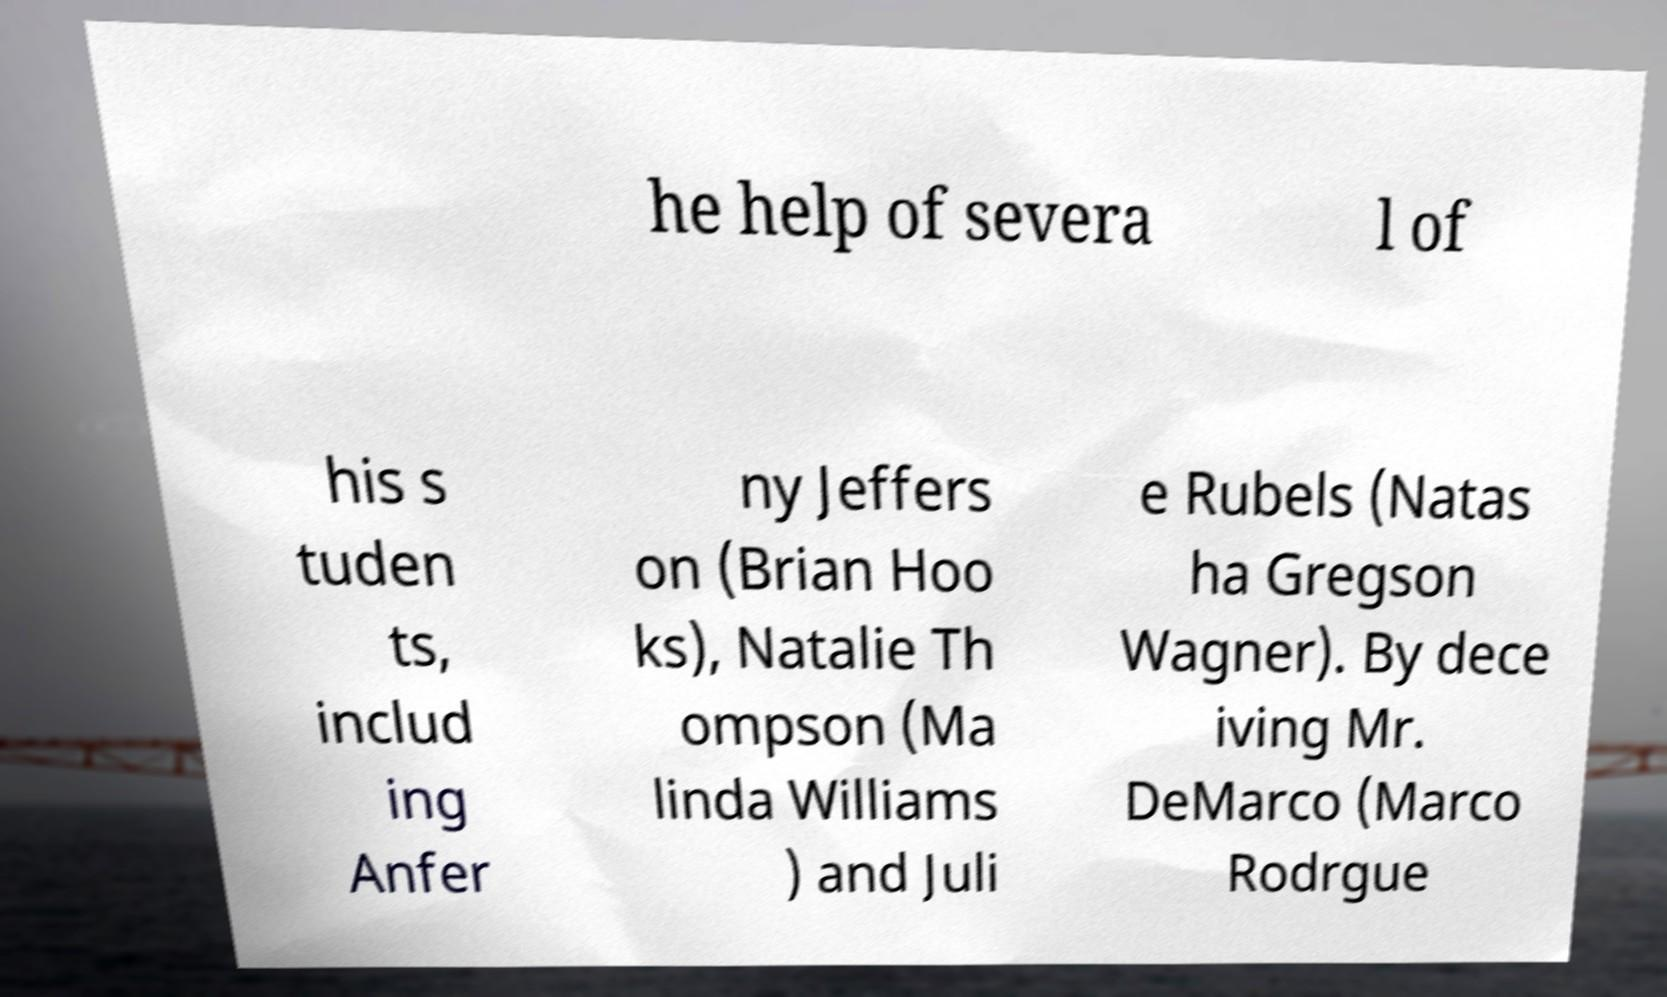For documentation purposes, I need the text within this image transcribed. Could you provide that? he help of severa l of his s tuden ts, includ ing Anfer ny Jeffers on (Brian Hoo ks), Natalie Th ompson (Ma linda Williams ) and Juli e Rubels (Natas ha Gregson Wagner). By dece iving Mr. DeMarco (Marco Rodrgue 